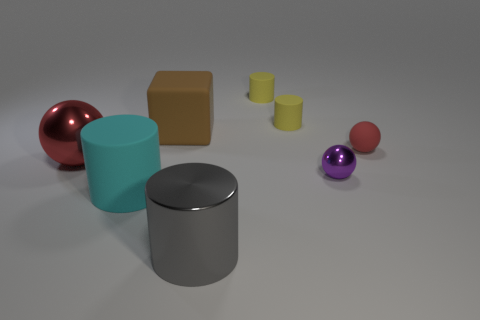Subtract 1 cylinders. How many cylinders are left? 3 Add 1 large cyan matte balls. How many objects exist? 9 Subtract all blocks. How many objects are left? 7 Add 7 tiny yellow cylinders. How many tiny yellow cylinders exist? 9 Subtract 0 gray blocks. How many objects are left? 8 Subtract all blue matte cubes. Subtract all small shiny objects. How many objects are left? 7 Add 5 gray things. How many gray things are left? 6 